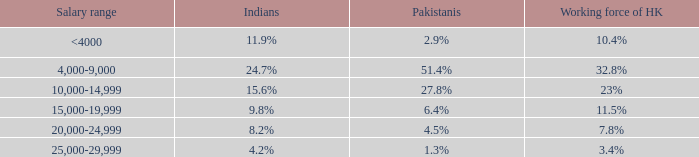If the workforce in hk accounts for 1 <4000. 